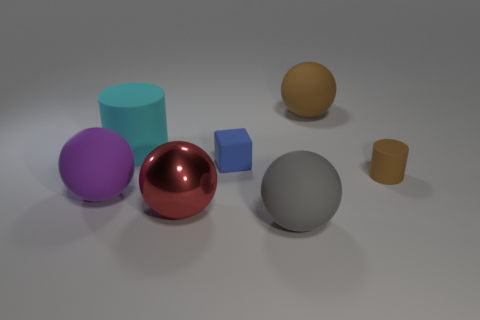What materials do the objects seem to be made of, based on their appearance? The objects appear to be rendered with different material properties. The large red sphere has a reflective, metallic look, suggesting it could be made of polished metal. The blue cube and the brown cylinder seem to have a matte finish, possibly indicating a plastic or painted wood material. The gray sphere, purple cylinder, and yellow sphere also have a matte surface, giving the impression of a nonmetallic, possibly rubbery or plastic nature. 